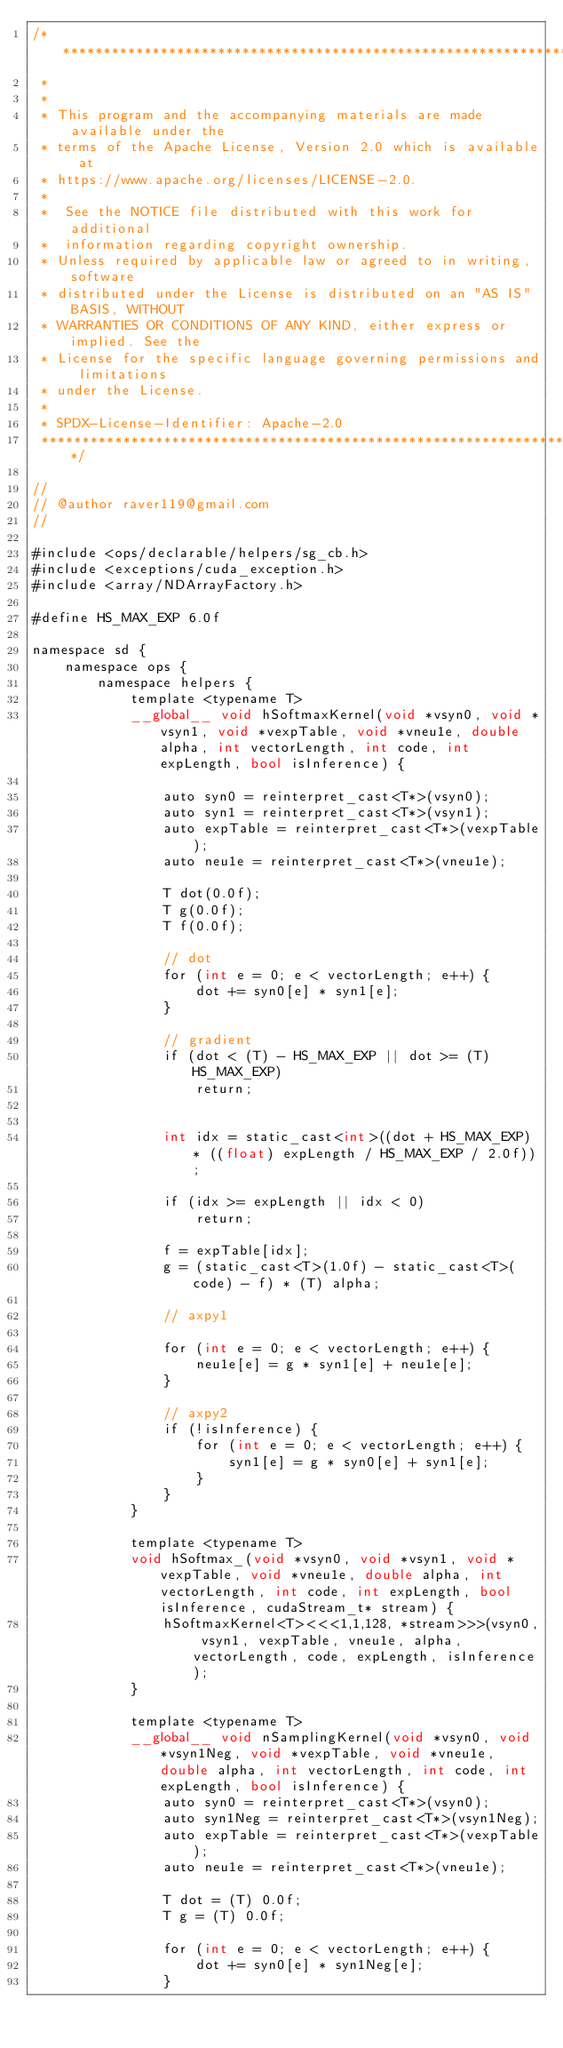<code> <loc_0><loc_0><loc_500><loc_500><_Cuda_>/* ******************************************************************************
 *
 *
 * This program and the accompanying materials are made available under the
 * terms of the Apache License, Version 2.0 which is available at
 * https://www.apache.org/licenses/LICENSE-2.0.
 *
 *  See the NOTICE file distributed with this work for additional
 *  information regarding copyright ownership.
 * Unless required by applicable law or agreed to in writing, software
 * distributed under the License is distributed on an "AS IS" BASIS, WITHOUT
 * WARRANTIES OR CONDITIONS OF ANY KIND, either express or implied. See the
 * License for the specific language governing permissions and limitations
 * under the License.
 *
 * SPDX-License-Identifier: Apache-2.0
 ******************************************************************************/

//
// @author raver119@gmail.com
//

#include <ops/declarable/helpers/sg_cb.h>
#include <exceptions/cuda_exception.h>
#include <array/NDArrayFactory.h>

#define HS_MAX_EXP 6.0f

namespace sd {
    namespace ops {
        namespace helpers {
            template <typename T>
            __global__ void hSoftmaxKernel(void *vsyn0, void *vsyn1, void *vexpTable, void *vneu1e, double alpha, int vectorLength, int code, int expLength, bool isInference) {

                auto syn0 = reinterpret_cast<T*>(vsyn0);
                auto syn1 = reinterpret_cast<T*>(vsyn1);
                auto expTable = reinterpret_cast<T*>(vexpTable);
                auto neu1e = reinterpret_cast<T*>(vneu1e);

                T dot(0.0f);
                T g(0.0f);
                T f(0.0f);

                // dot
                for (int e = 0; e < vectorLength; e++) {
                    dot += syn0[e] * syn1[e];
                }

                // gradient
                if (dot < (T) - HS_MAX_EXP || dot >= (T) HS_MAX_EXP)
                    return;


                int idx = static_cast<int>((dot + HS_MAX_EXP) * ((float) expLength / HS_MAX_EXP / 2.0f));

                if (idx >= expLength || idx < 0)
                    return;

                f = expTable[idx];
                g = (static_cast<T>(1.0f) - static_cast<T>(code) - f) * (T) alpha;

                // axpy1

                for (int e = 0; e < vectorLength; e++) {
                    neu1e[e] = g * syn1[e] + neu1e[e];
                }

                // axpy2
                if (!isInference) {
                    for (int e = 0; e < vectorLength; e++) {
                        syn1[e] = g * syn0[e] + syn1[e];
                    }
                }
            }

            template <typename T>
            void hSoftmax_(void *vsyn0, void *vsyn1, void *vexpTable, void *vneu1e, double alpha, int vectorLength, int code, int expLength, bool isInference, cudaStream_t* stream) {
                hSoftmaxKernel<T><<<1,1,128, *stream>>>(vsyn0, vsyn1, vexpTable, vneu1e, alpha, vectorLength, code, expLength, isInference);
            }

            template <typename T>
            __global__ void nSamplingKernel(void *vsyn0, void *vsyn1Neg, void *vexpTable, void *vneu1e, double alpha, int vectorLength, int code, int expLength, bool isInference) {
                auto syn0 = reinterpret_cast<T*>(vsyn0);
                auto syn1Neg = reinterpret_cast<T*>(vsyn1Neg);
                auto expTable = reinterpret_cast<T*>(vexpTable);
                auto neu1e = reinterpret_cast<T*>(vneu1e);

                T dot = (T) 0.0f;
                T g = (T) 0.0f;

                for (int e = 0; e < vectorLength; e++) {
                    dot += syn0[e] * syn1Neg[e];
                }
</code> 